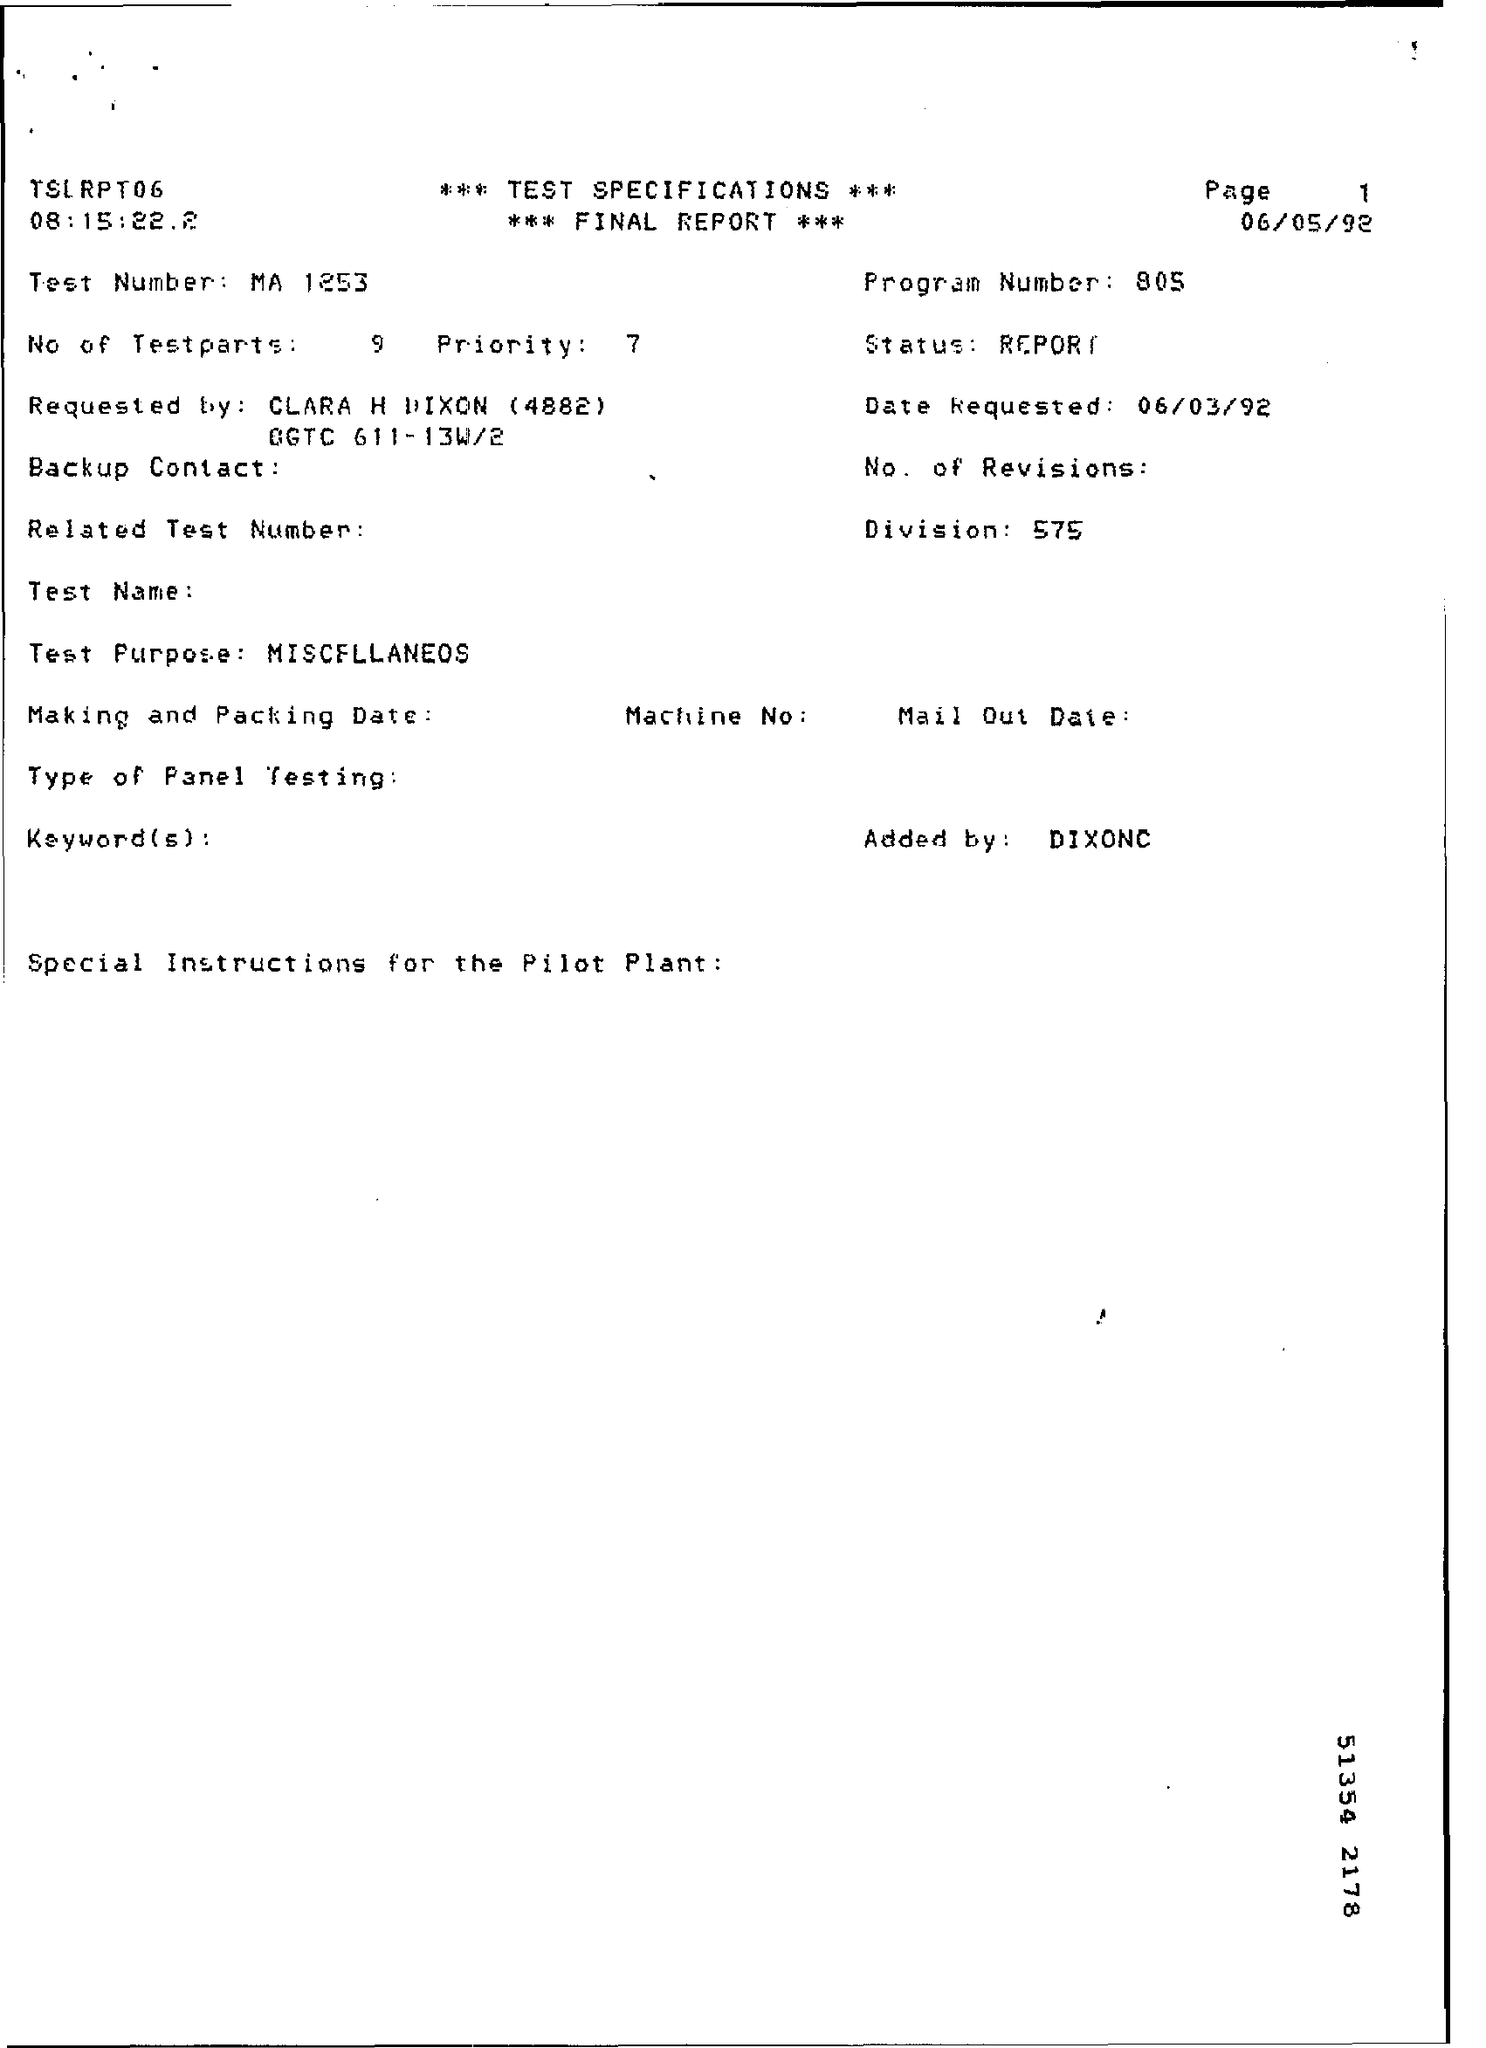Give some essential details in this illustration. The report indicates that there are 9 test parts. The division mentioned in the report is 575. The final report mentions a program number of 805. The final report contains the request for the date of 06/03/92. The test number reported in the final report is MA 1253. 